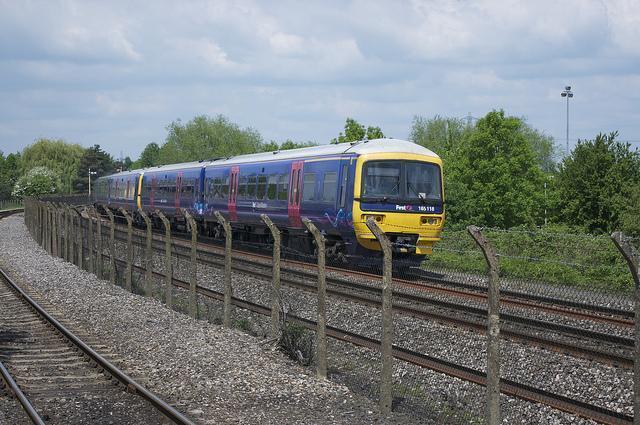How many train cars are there?
Give a very brief answer. 3. 